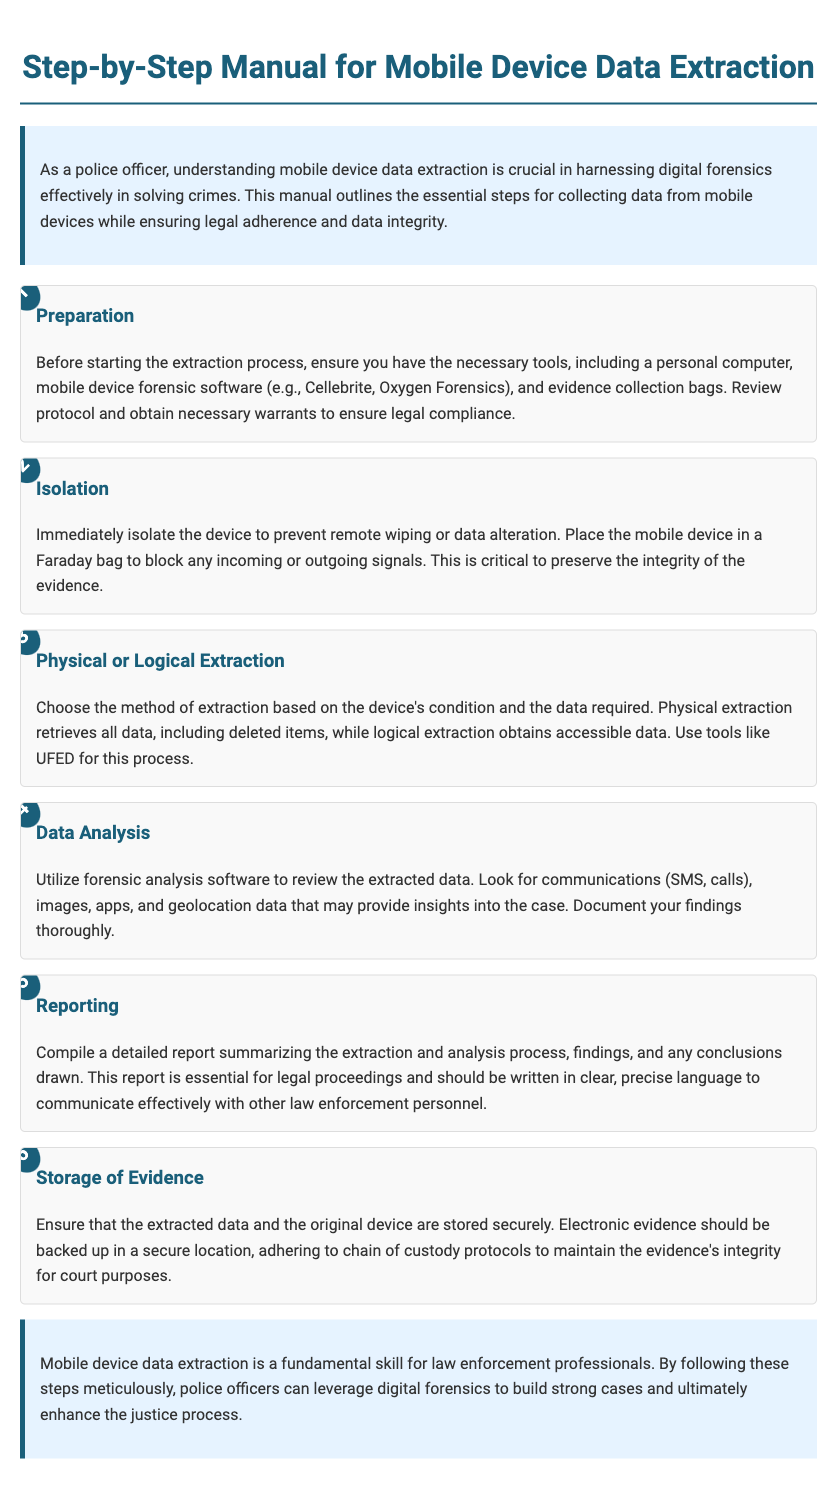What is the title of the manual? The title is stated prominently at the top of the document, identifying the focus on mobile device data extraction.
Answer: Step-by-Step Manual for Mobile Device Data Extraction What is the first step in the data extraction process? The document outlines the steps in a sequence, and the first step listed is "Preparation."
Answer: Preparation What type of extraction retrieves deleted data? The document specifies the types of extraction methods and identifies which one allows for retrieving deleted items.
Answer: Physical extraction Which software is mentioned for data extraction? The document lists specific tools that are appropriate for mobile device data extraction.
Answer: Cellebrite, Oxygen Forensics What should be used to block signals during isolation? The document indicates a specific item that is critical for isolating the device to preserve evidence integrity.
Answer: Faraday bag What is crucial to maintain the evidence's integrity? The document emphasizes a procedure that must be followed to ensure the physical evidence remains trustworthy for legal proceedings.
Answer: Chain of custody protocols What is the main purpose of the report compiled after data extraction? The document specifies the role of the report in legal contexts in relation to the data extraction and analysis.
Answer: Legal proceedings What does data analysis review? The document delineates what types of information should be examined during the analysis stage of data extraction.
Answer: Communications, images, apps, geolocation data What is the final section of the document about? The conclusion reflects on the importance of the steps outlined and their implications for law enforcement.
Answer: Mobile device data extraction is a fundamental skill for law enforcement professionals 